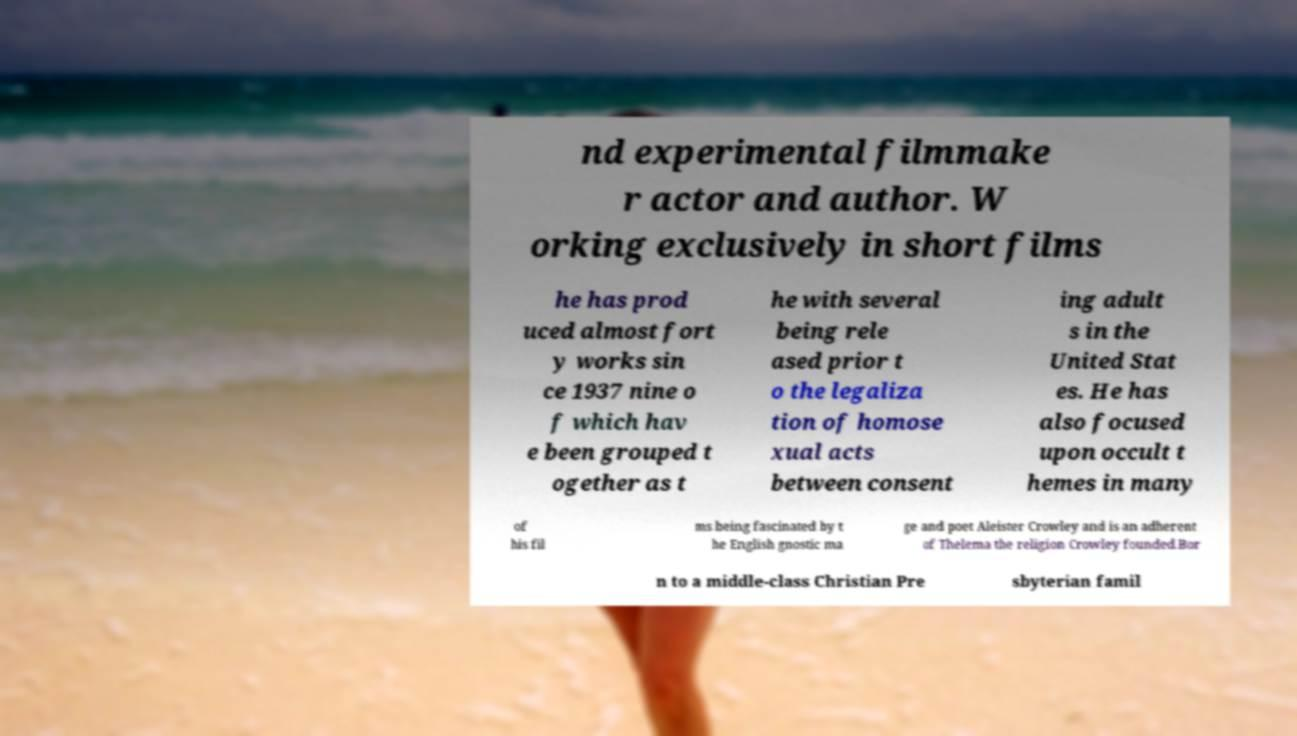Can you read and provide the text displayed in the image?This photo seems to have some interesting text. Can you extract and type it out for me? nd experimental filmmake r actor and author. W orking exclusively in short films he has prod uced almost fort y works sin ce 1937 nine o f which hav e been grouped t ogether as t he with several being rele ased prior t o the legaliza tion of homose xual acts between consent ing adult s in the United Stat es. He has also focused upon occult t hemes in many of his fil ms being fascinated by t he English gnostic ma ge and poet Aleister Crowley and is an adherent of Thelema the religion Crowley founded.Bor n to a middle-class Christian Pre sbyterian famil 